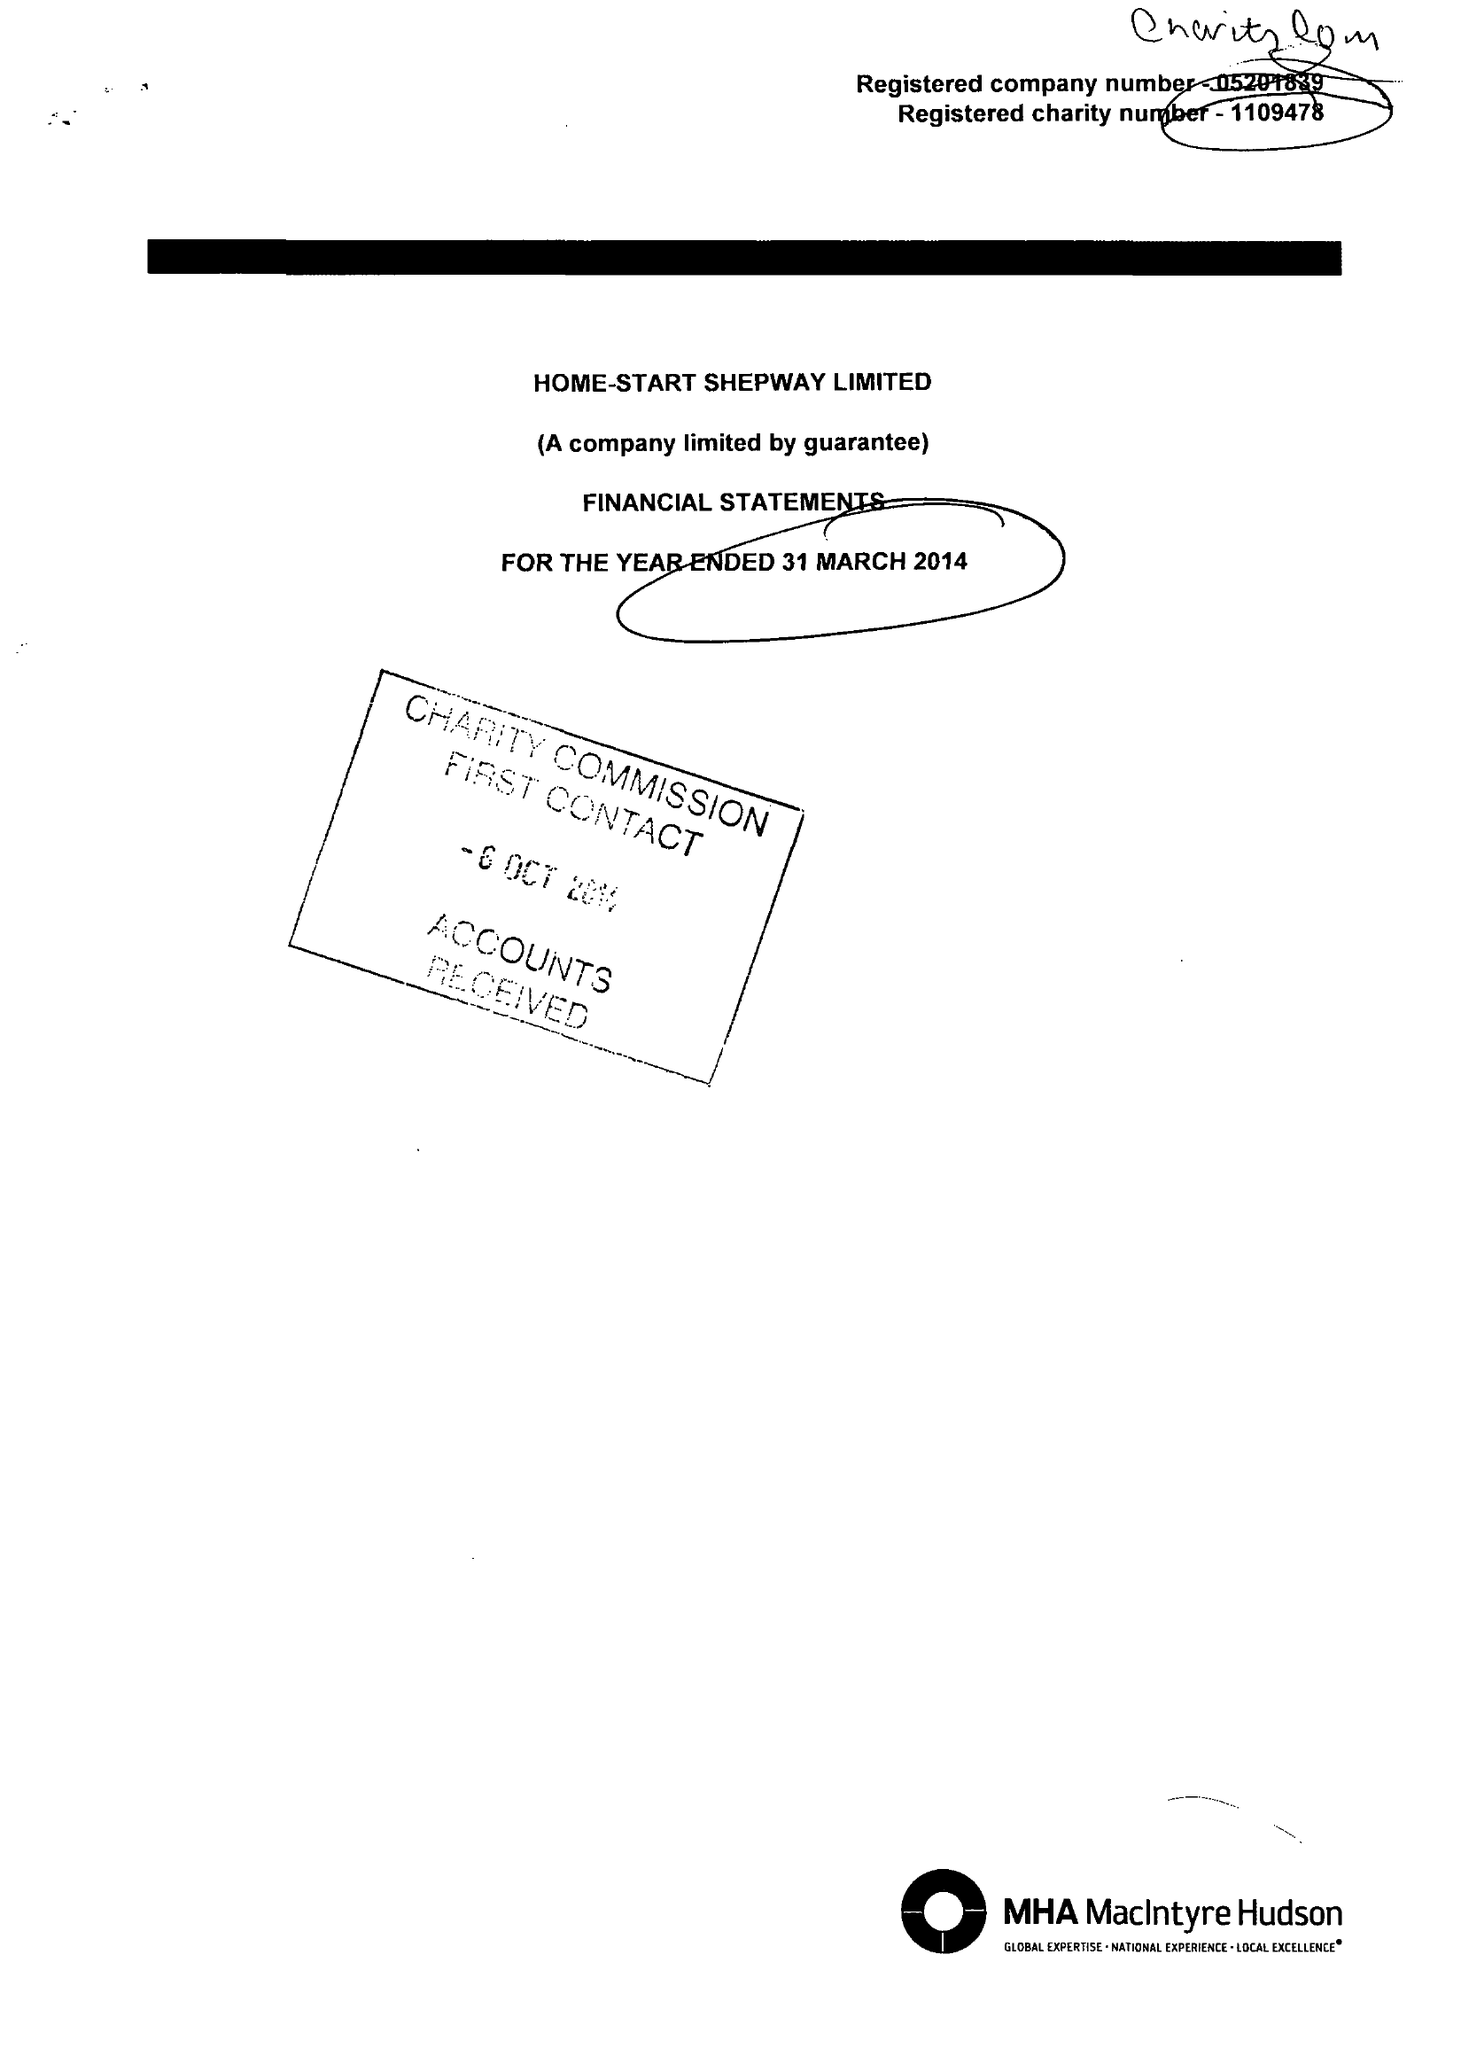What is the value for the address__postcode?
Answer the question using a single word or phrase. CT20 2AS 